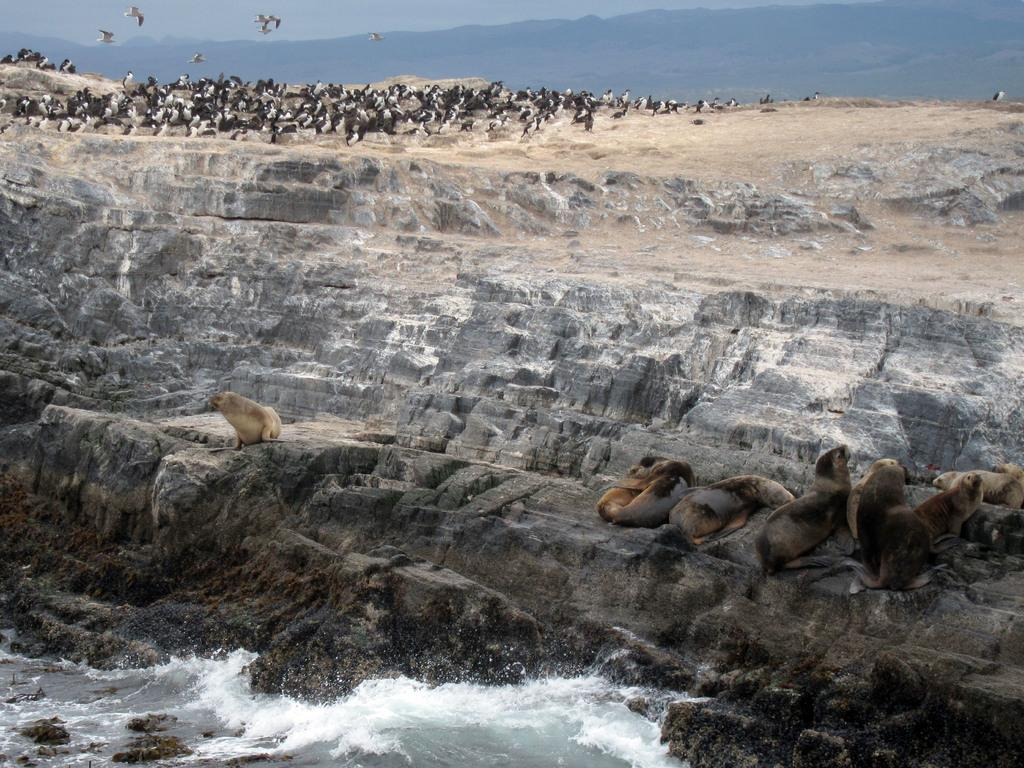What animals are on the rock surface in the image? There are seals on a rock surface in the image. What is located at the bottom of the image? There is a water body at the bottom of the image. What other animals can be seen in the image? There are penguins in the top part of the image. What can be seen in the background of the image? There are hills visible in the background of the image. What else is present in the sky in the image? There are birds in the sky in the image. What type of silverware is being used by the seals in the image? There is no silverware present in the image; the seals are on a rock surface. Can you tell me how many ice cubes are floating in the water body in the image? There is no mention of ice cubes in the image; it features a water body with seals and penguins. 